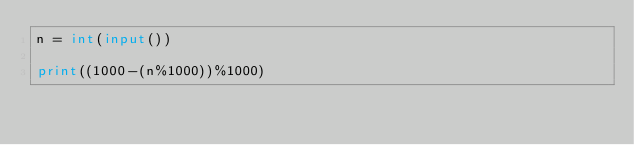Convert code to text. <code><loc_0><loc_0><loc_500><loc_500><_Python_>n = int(input())

print((1000-(n%1000))%1000)
</code> 